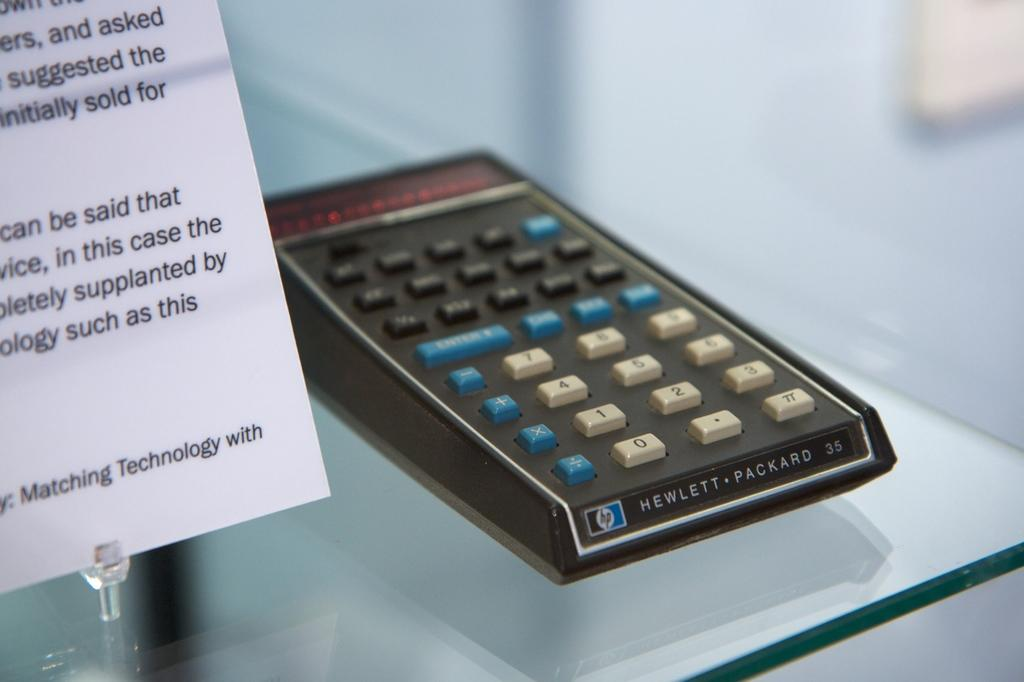Provide a one-sentence caption for the provided image. An HP calculator with blue, black and white buttons is on display. 